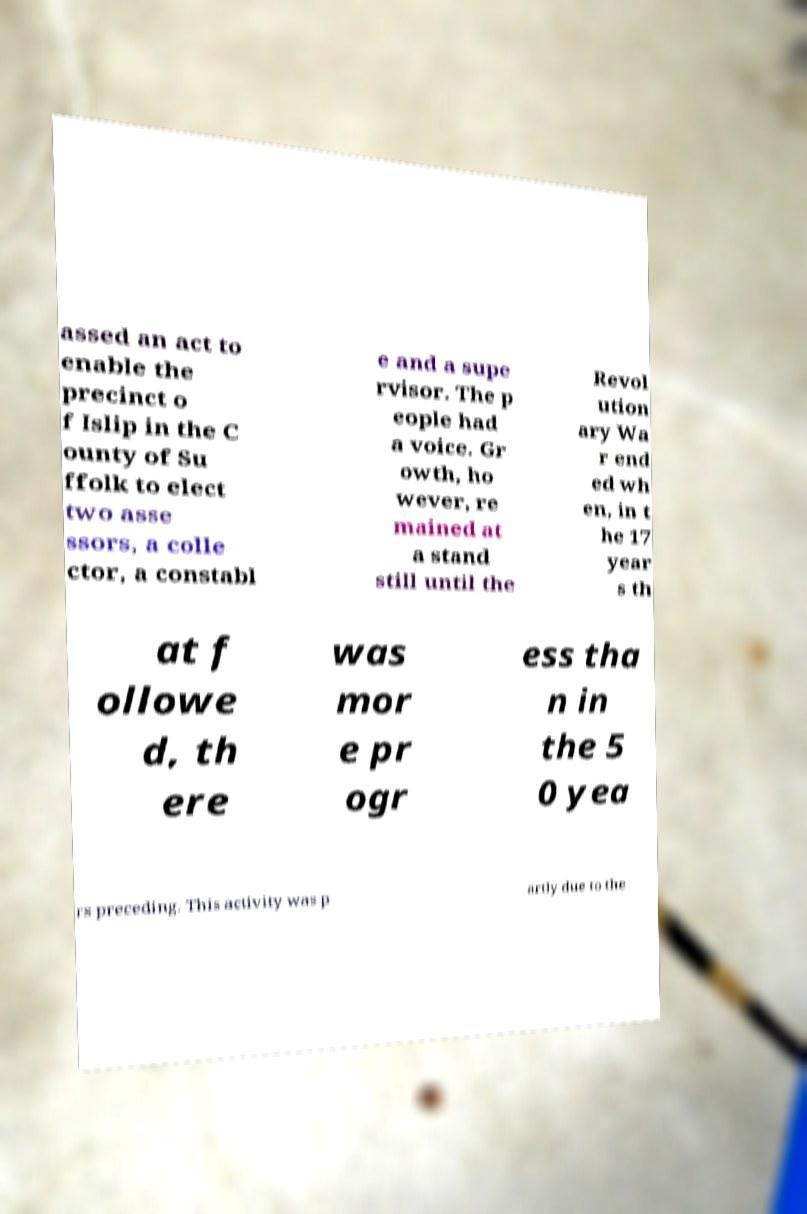Can you read and provide the text displayed in the image?This photo seems to have some interesting text. Can you extract and type it out for me? assed an act to enable the precinct o f Islip in the C ounty of Su ffolk to elect two asse ssors, a colle ctor, a constabl e and a supe rvisor. The p eople had a voice. Gr owth, ho wever, re mained at a stand still until the Revol ution ary Wa r end ed wh en, in t he 17 year s th at f ollowe d, th ere was mor e pr ogr ess tha n in the 5 0 yea rs preceding. This activity was p artly due to the 